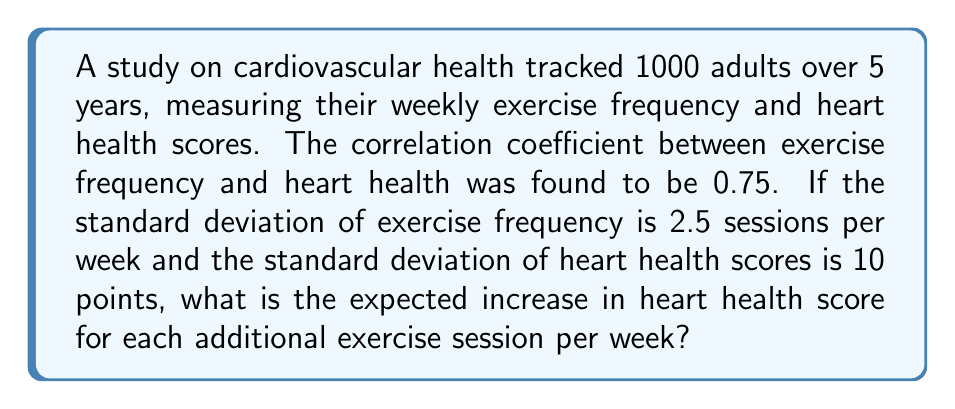Teach me how to tackle this problem. To solve this problem, we'll use the formula for the slope of the regression line:

$$ b = r \cdot \frac{s_y}{s_x} $$

Where:
$b$ = slope (expected increase in heart health score per exercise session)
$r$ = correlation coefficient
$s_y$ = standard deviation of heart health scores
$s_x$ = standard deviation of exercise frequency

Step 1: Identify the given values
$r = 0.75$
$s_y = 10$ points
$s_x = 2.5$ sessions per week

Step 2: Plug the values into the formula
$$ b = 0.75 \cdot \frac{10}{2.5} $$

Step 3: Simplify
$$ b = 0.75 \cdot 4 = 3 $$

Therefore, for each additional exercise session per week, we expect the heart health score to increase by 3 points.
Answer: 3 points 